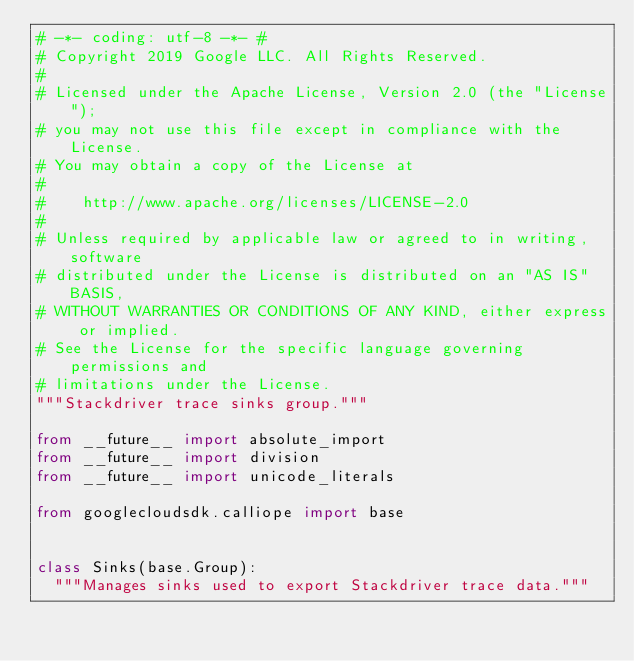Convert code to text. <code><loc_0><loc_0><loc_500><loc_500><_Python_># -*- coding: utf-8 -*- #
# Copyright 2019 Google LLC. All Rights Reserved.
#
# Licensed under the Apache License, Version 2.0 (the "License");
# you may not use this file except in compliance with the License.
# You may obtain a copy of the License at
#
#    http://www.apache.org/licenses/LICENSE-2.0
#
# Unless required by applicable law or agreed to in writing, software
# distributed under the License is distributed on an "AS IS" BASIS,
# WITHOUT WARRANTIES OR CONDITIONS OF ANY KIND, either express or implied.
# See the License for the specific language governing permissions and
# limitations under the License.
"""Stackdriver trace sinks group."""

from __future__ import absolute_import
from __future__ import division
from __future__ import unicode_literals

from googlecloudsdk.calliope import base


class Sinks(base.Group):
  """Manages sinks used to export Stackdriver trace data."""
</code> 